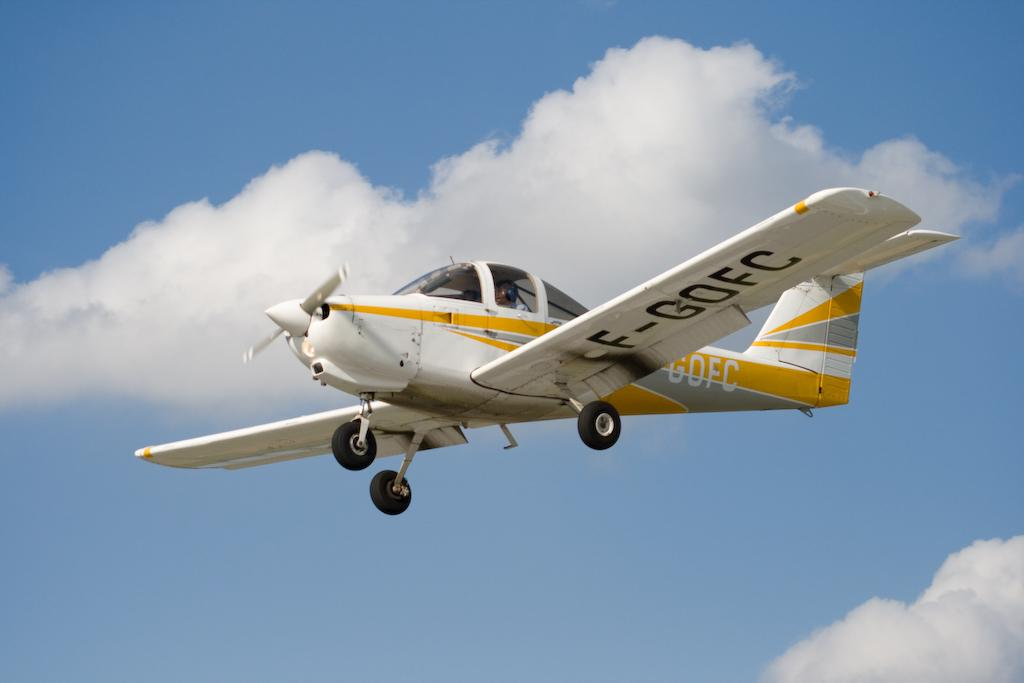Provide a one-sentence caption for the provided image. A plane labeled F-GOFC flies through the air. 